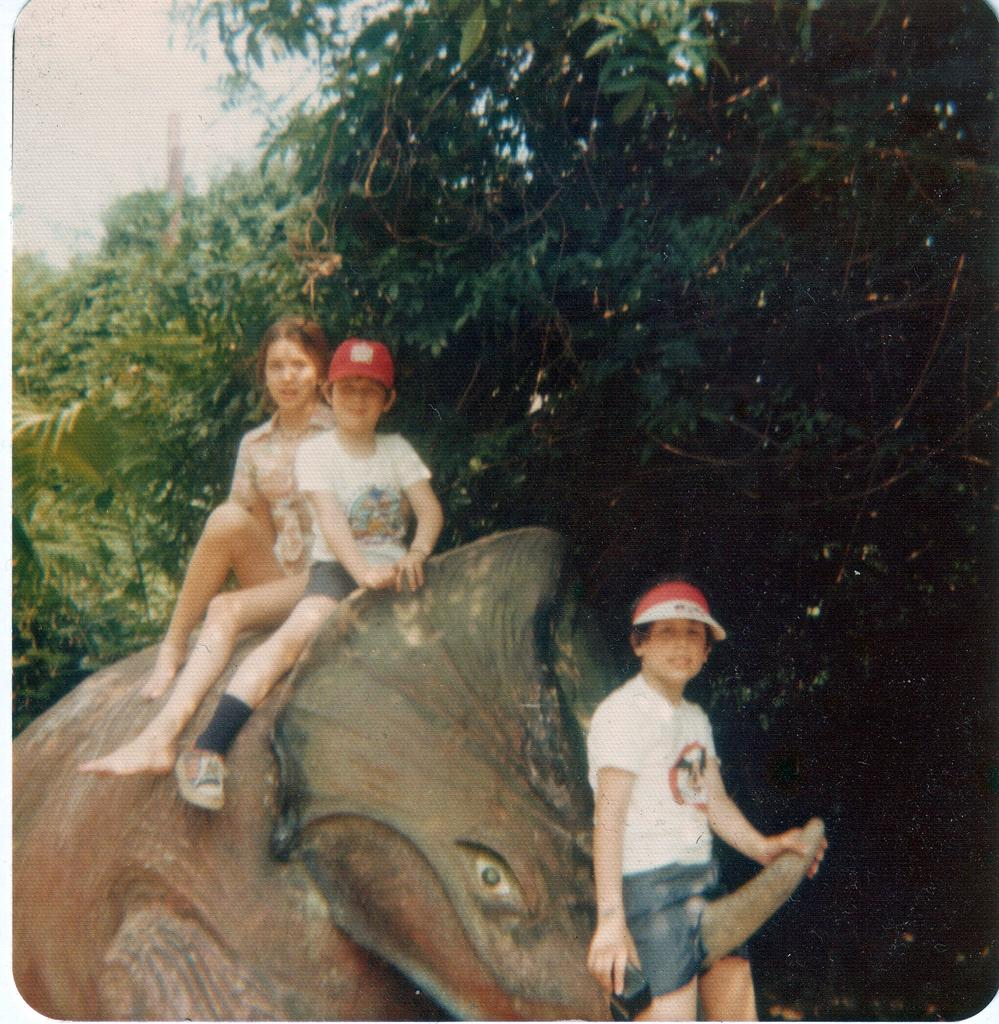How many people are in the image? There are two people in the image, a boy and a girl. What are the boy and girl doing in the image? Both the boy and girl are sitting on a rhinoceros. Can you describe the position of the boy in the image? The boy is sitting on the tusk of a rhinoceros. What type of flower is the boy holding in the image? There is no flower present in the image; the boy is sitting on a rhinoceros. 